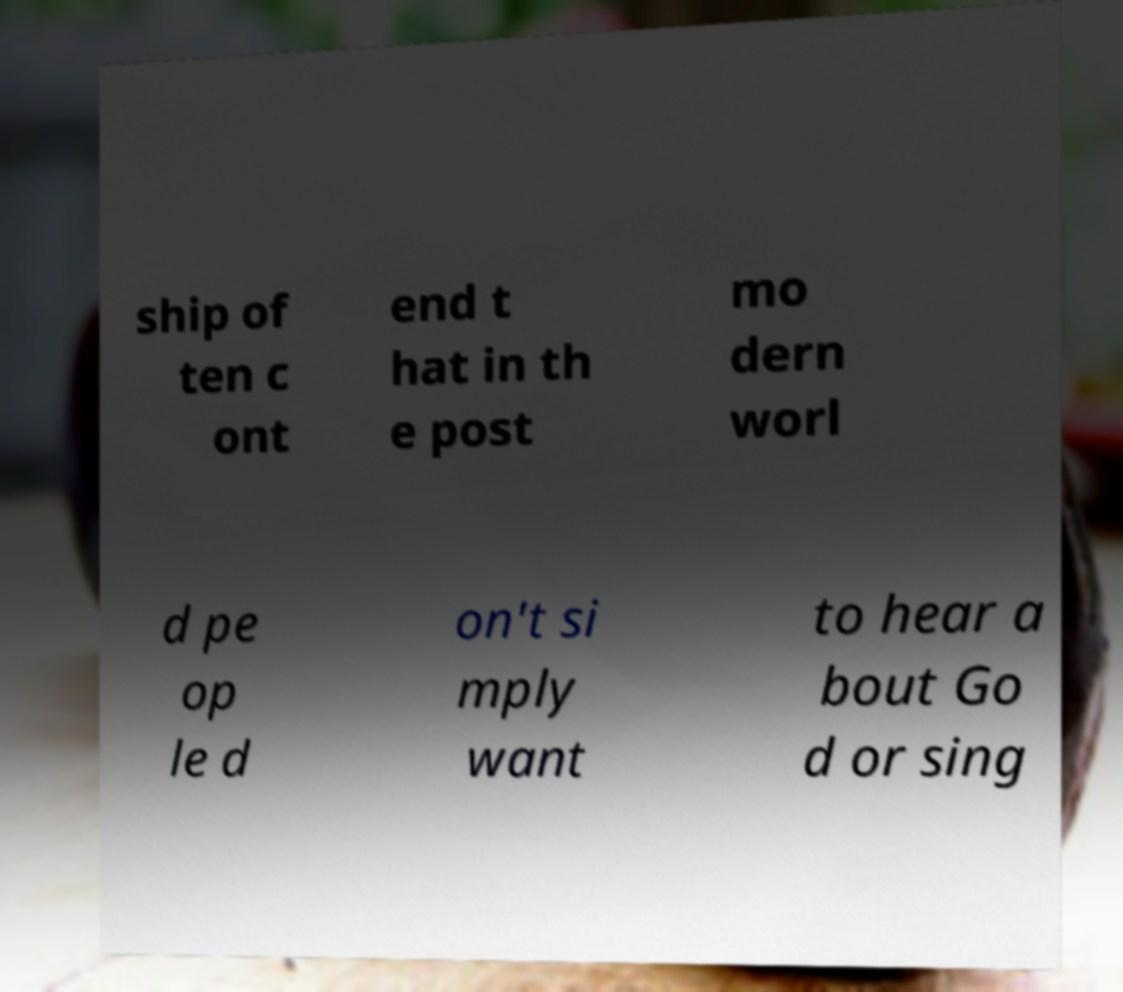Could you assist in decoding the text presented in this image and type it out clearly? ship of ten c ont end t hat in th e post mo dern worl d pe op le d on't si mply want to hear a bout Go d or sing 